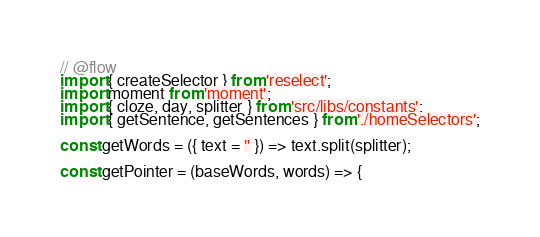Convert code to text. <code><loc_0><loc_0><loc_500><loc_500><_JavaScript_>// @flow
import { createSelector } from 'reselect';
import moment from 'moment';
import { cloze, day, splitter } from 'src/libs/constants';
import { getSentence, getSentences } from './homeSelectors';

const getWords = ({ text = '' }) => text.split(splitter);

const getPointer = (baseWords, words) => {</code> 